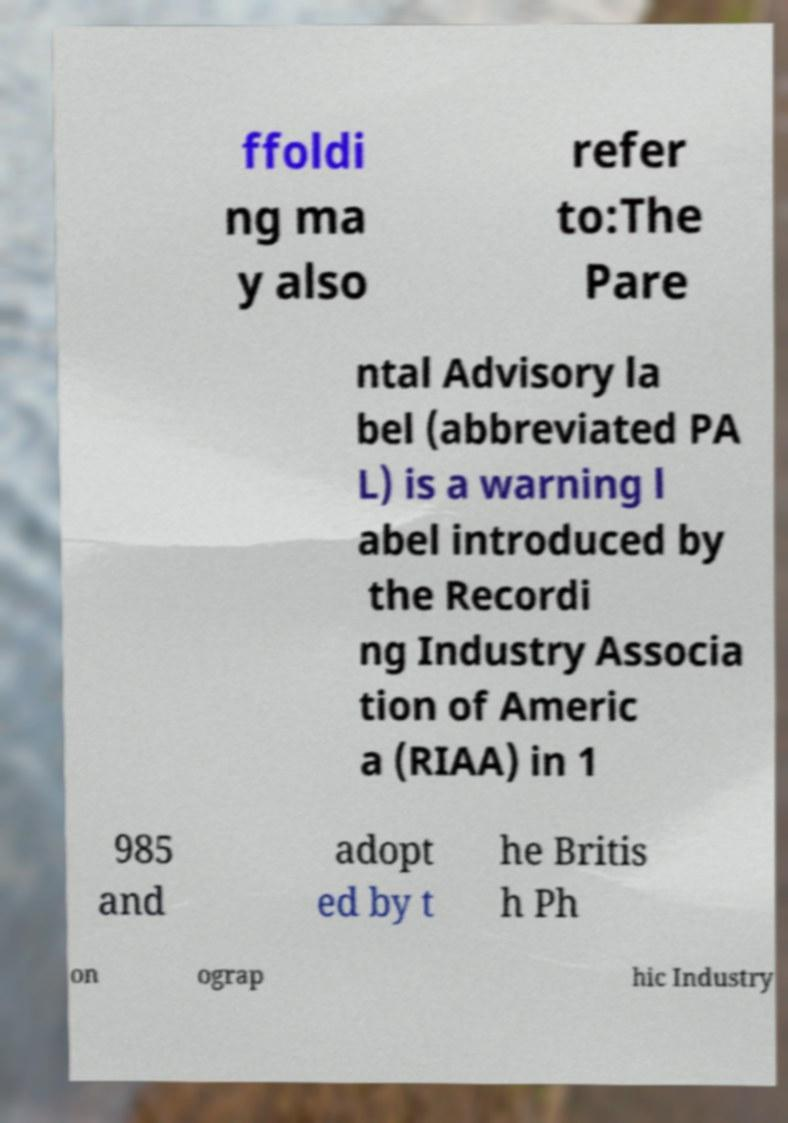What messages or text are displayed in this image? I need them in a readable, typed format. ffoldi ng ma y also refer to:The Pare ntal Advisory la bel (abbreviated PA L) is a warning l abel introduced by the Recordi ng Industry Associa tion of Americ a (RIAA) in 1 985 and adopt ed by t he Britis h Ph on ograp hic Industry 